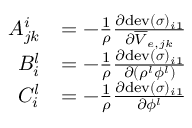<formula> <loc_0><loc_0><loc_500><loc_500>\begin{array} { r l } { A _ { j k } ^ { i } } & { = - \frac { 1 } { \rho } \frac { \partial d e v ( \boldsymbol \sigma ) _ { i 1 } } { \partial \overline { V } _ { e , j k } } } \\ { B _ { i } ^ { l } } & { = - \frac { 1 } { \rho } \frac { \partial d e v ( \boldsymbol \sigma ) _ { i 1 } } { \partial ( \rho ^ { l } \phi ^ { l } ) } } \\ { C _ { i } ^ { l } } & { = - \frac { 1 } { \rho } \frac { \partial d e v ( \boldsymbol \sigma ) _ { i 1 } } { \partial \phi ^ { l } } } \end{array}</formula> 